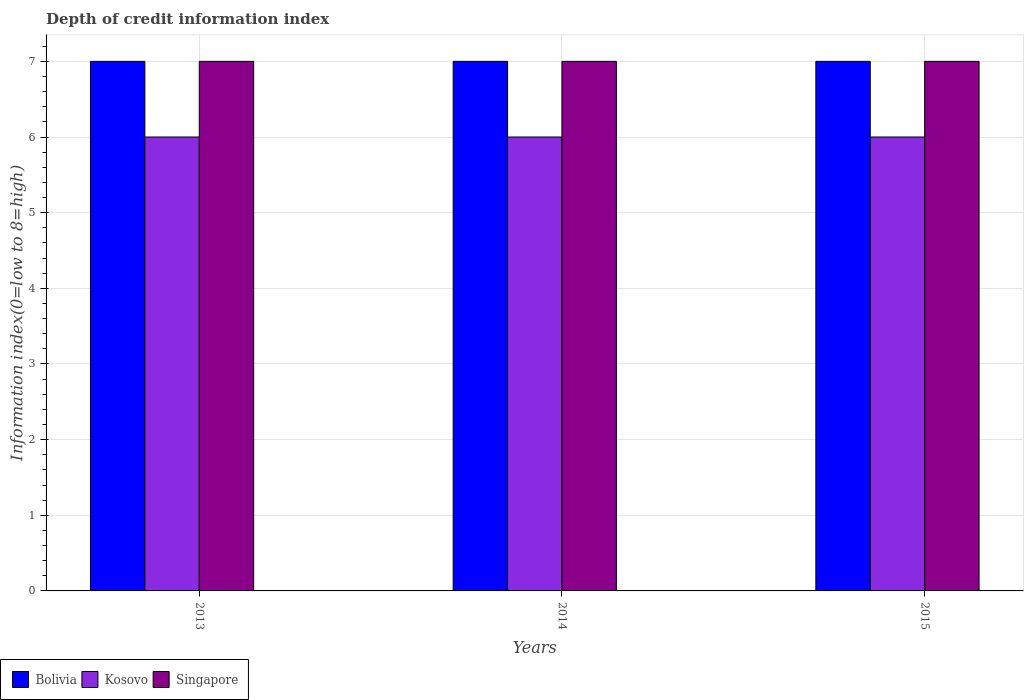How many different coloured bars are there?
Ensure brevity in your answer.  3. How many groups of bars are there?
Provide a succinct answer. 3. Are the number of bars per tick equal to the number of legend labels?
Provide a short and direct response. Yes. Are the number of bars on each tick of the X-axis equal?
Offer a very short reply. Yes. How many bars are there on the 2nd tick from the left?
Offer a very short reply. 3. What is the label of the 1st group of bars from the left?
Give a very brief answer. 2013. In how many cases, is the number of bars for a given year not equal to the number of legend labels?
Offer a terse response. 0. Across all years, what is the minimum information index in Singapore?
Provide a succinct answer. 7. In which year was the information index in Singapore maximum?
Your response must be concise. 2013. In which year was the information index in Kosovo minimum?
Provide a short and direct response. 2013. What is the total information index in Kosovo in the graph?
Offer a terse response. 18. What is the difference between the information index in Singapore in 2014 and the information index in Kosovo in 2013?
Give a very brief answer. 1. What is the average information index in Bolivia per year?
Provide a short and direct response. 7. Is the difference between the information index in Singapore in 2013 and 2015 greater than the difference between the information index in Bolivia in 2013 and 2015?
Ensure brevity in your answer.  No. What is the difference between the highest and the second highest information index in Singapore?
Offer a very short reply. 0. What is the difference between the highest and the lowest information index in Bolivia?
Give a very brief answer. 0. In how many years, is the information index in Bolivia greater than the average information index in Bolivia taken over all years?
Provide a succinct answer. 0. Is the sum of the information index in Kosovo in 2014 and 2015 greater than the maximum information index in Bolivia across all years?
Your response must be concise. Yes. What does the 2nd bar from the left in 2014 represents?
Offer a very short reply. Kosovo. What does the 1st bar from the right in 2015 represents?
Your response must be concise. Singapore. Is it the case that in every year, the sum of the information index in Kosovo and information index in Bolivia is greater than the information index in Singapore?
Your response must be concise. Yes. How many bars are there?
Keep it short and to the point. 9. Are all the bars in the graph horizontal?
Ensure brevity in your answer.  No. What is the difference between two consecutive major ticks on the Y-axis?
Your answer should be compact. 1. How many legend labels are there?
Your answer should be compact. 3. What is the title of the graph?
Offer a very short reply. Depth of credit information index. What is the label or title of the Y-axis?
Make the answer very short. Information index(0=low to 8=high). What is the Information index(0=low to 8=high) of Bolivia in 2013?
Offer a very short reply. 7. What is the Information index(0=low to 8=high) of Bolivia in 2014?
Your answer should be very brief. 7. What is the Information index(0=low to 8=high) of Bolivia in 2015?
Provide a succinct answer. 7. What is the Information index(0=low to 8=high) of Kosovo in 2015?
Provide a short and direct response. 6. What is the Information index(0=low to 8=high) of Singapore in 2015?
Provide a short and direct response. 7. Across all years, what is the maximum Information index(0=low to 8=high) in Bolivia?
Give a very brief answer. 7. Across all years, what is the minimum Information index(0=low to 8=high) of Bolivia?
Offer a terse response. 7. Across all years, what is the minimum Information index(0=low to 8=high) in Singapore?
Your answer should be very brief. 7. What is the total Information index(0=low to 8=high) of Bolivia in the graph?
Your answer should be compact. 21. What is the total Information index(0=low to 8=high) in Kosovo in the graph?
Your response must be concise. 18. What is the difference between the Information index(0=low to 8=high) in Bolivia in 2013 and that in 2014?
Provide a short and direct response. 0. What is the difference between the Information index(0=low to 8=high) in Kosovo in 2013 and that in 2014?
Offer a very short reply. 0. What is the difference between the Information index(0=low to 8=high) in Singapore in 2013 and that in 2015?
Give a very brief answer. 0. What is the difference between the Information index(0=low to 8=high) of Bolivia in 2013 and the Information index(0=low to 8=high) of Singapore in 2014?
Make the answer very short. 0. What is the difference between the Information index(0=low to 8=high) of Kosovo in 2013 and the Information index(0=low to 8=high) of Singapore in 2015?
Your answer should be very brief. -1. What is the difference between the Information index(0=low to 8=high) in Bolivia in 2014 and the Information index(0=low to 8=high) in Kosovo in 2015?
Offer a very short reply. 1. What is the difference between the Information index(0=low to 8=high) of Bolivia in 2014 and the Information index(0=low to 8=high) of Singapore in 2015?
Your answer should be compact. 0. What is the average Information index(0=low to 8=high) in Bolivia per year?
Give a very brief answer. 7. What is the average Information index(0=low to 8=high) in Kosovo per year?
Make the answer very short. 6. What is the average Information index(0=low to 8=high) in Singapore per year?
Your answer should be compact. 7. In the year 2013, what is the difference between the Information index(0=low to 8=high) in Bolivia and Information index(0=low to 8=high) in Singapore?
Ensure brevity in your answer.  0. In the year 2013, what is the difference between the Information index(0=low to 8=high) in Kosovo and Information index(0=low to 8=high) in Singapore?
Make the answer very short. -1. In the year 2014, what is the difference between the Information index(0=low to 8=high) in Bolivia and Information index(0=low to 8=high) in Kosovo?
Provide a succinct answer. 1. In the year 2014, what is the difference between the Information index(0=low to 8=high) in Bolivia and Information index(0=low to 8=high) in Singapore?
Your response must be concise. 0. In the year 2014, what is the difference between the Information index(0=low to 8=high) in Kosovo and Information index(0=low to 8=high) in Singapore?
Your response must be concise. -1. In the year 2015, what is the difference between the Information index(0=low to 8=high) of Bolivia and Information index(0=low to 8=high) of Kosovo?
Ensure brevity in your answer.  1. In the year 2015, what is the difference between the Information index(0=low to 8=high) of Bolivia and Information index(0=low to 8=high) of Singapore?
Give a very brief answer. 0. In the year 2015, what is the difference between the Information index(0=low to 8=high) in Kosovo and Information index(0=low to 8=high) in Singapore?
Your answer should be very brief. -1. What is the ratio of the Information index(0=low to 8=high) in Bolivia in 2013 to that in 2014?
Give a very brief answer. 1. What is the ratio of the Information index(0=low to 8=high) of Singapore in 2013 to that in 2014?
Your answer should be compact. 1. What is the ratio of the Information index(0=low to 8=high) of Bolivia in 2013 to that in 2015?
Keep it short and to the point. 1. What is the ratio of the Information index(0=low to 8=high) of Bolivia in 2014 to that in 2015?
Your answer should be compact. 1. What is the difference between the highest and the second highest Information index(0=low to 8=high) of Bolivia?
Provide a succinct answer. 0. What is the difference between the highest and the second highest Information index(0=low to 8=high) of Kosovo?
Ensure brevity in your answer.  0. What is the difference between the highest and the second highest Information index(0=low to 8=high) in Singapore?
Ensure brevity in your answer.  0. What is the difference between the highest and the lowest Information index(0=low to 8=high) of Bolivia?
Your response must be concise. 0. 